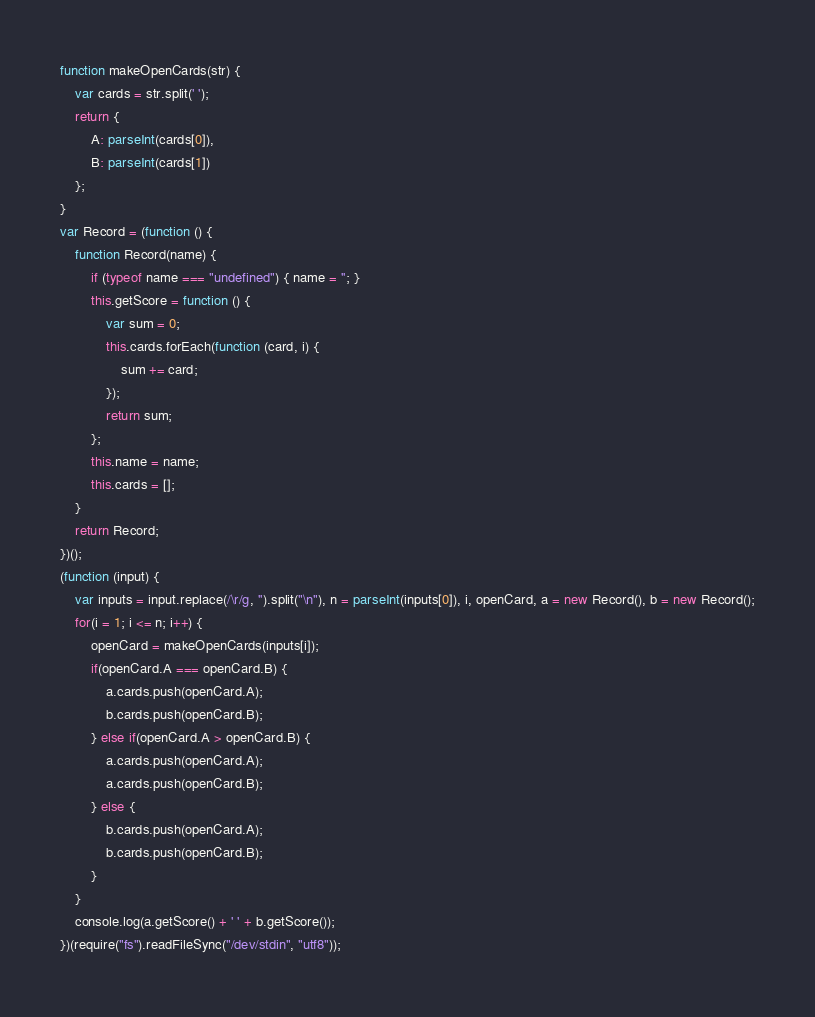Convert code to text. <code><loc_0><loc_0><loc_500><loc_500><_JavaScript_>function makeOpenCards(str) {
    var cards = str.split(' ');
    return {
        A: parseInt(cards[0]),
        B: parseInt(cards[1])
    };
}
var Record = (function () {
    function Record(name) {
        if (typeof name === "undefined") { name = ''; }
        this.getScore = function () {
            var sum = 0;
            this.cards.forEach(function (card, i) {
                sum += card;
            });
            return sum;
        };
        this.name = name;
        this.cards = [];
    }
    return Record;
})();
(function (input) {
    var inputs = input.replace(/\r/g, '').split("\n"), n = parseInt(inputs[0]), i, openCard, a = new Record(), b = new Record();
    for(i = 1; i <= n; i++) {
        openCard = makeOpenCards(inputs[i]);
        if(openCard.A === openCard.B) {
            a.cards.push(openCard.A);
            b.cards.push(openCard.B);
        } else if(openCard.A > openCard.B) {
            a.cards.push(openCard.A);
            a.cards.push(openCard.B);
        } else {
            b.cards.push(openCard.A);
            b.cards.push(openCard.B);
        }
    }
    console.log(a.getScore() + ' ' + b.getScore());
})(require("fs").readFileSync("/dev/stdin", "utf8"));</code> 